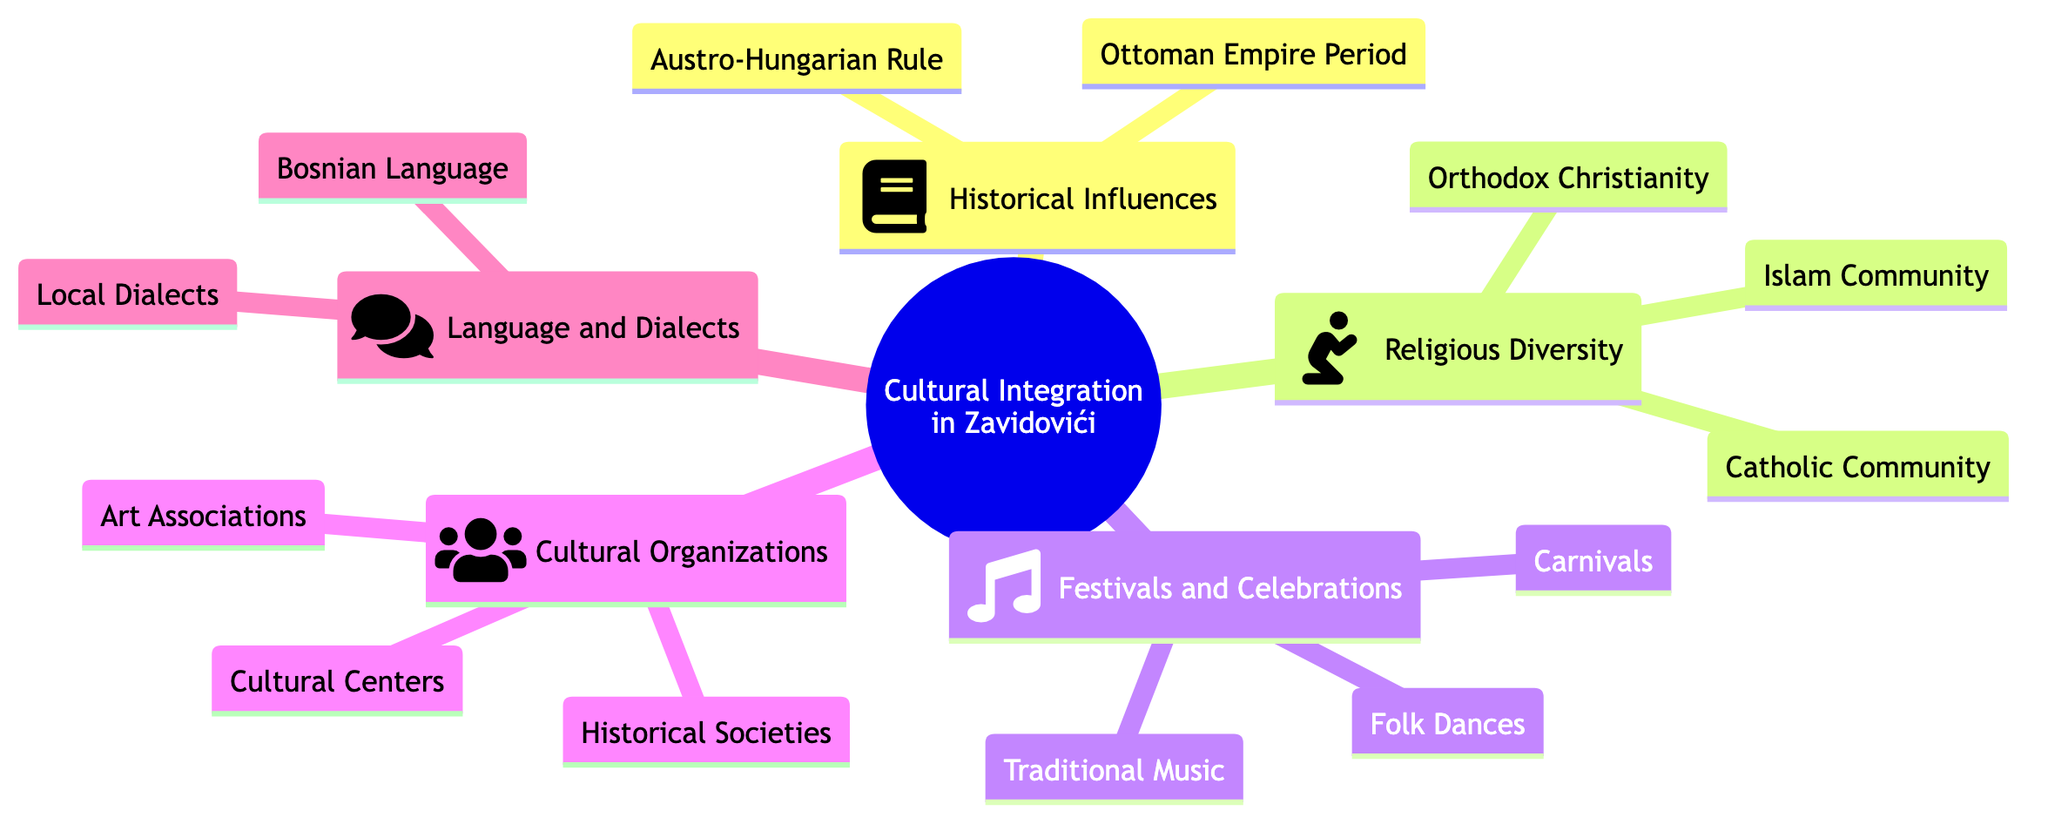What is the central theme of the concept map? The root node, titled "Cultural Integration in Zavidovići," is the main theme presented in the diagram. This can be identified as it is the top-level node and connects to several child nodes.
Answer: Cultural Integration in Zavidovići How many cultural organizations are listed in the diagram? The child node "Cultural Organizations" has three connections leading to "Cultural Centers," "Historical Societies," and "Art Associations," indicating there are three cultural organizations represented.
Answer: 3 Which historical period is included under Historical Influences? The child node "Historical Influences" specifically includes two periods: "Ottoman Empire Period" and "Austro-Hungarian Rule." This can be verified by looking at the connections from the Historical Influences node.
Answer: Ottoman Empire Period, Austro-Hungarian Rule What type of community is included under Religious Diversity? The "Religious Diversity" node includes three distinct communities: "Islam Community," "Orthodox Christianity," and "Catholic Community." Therefore, the answer is any of the communities listed under that node.
Answer: Islam Community Which festival type is included under Festivals and Celebrations? The node "Festivals and Celebrations" includes "Carnivals," "Folk Dances," and "Traditional Music." Any of these items would answer the question, but one example would be selected here.
Answer: Carnivals How many total child nodes are linked under Cultural Integration in Zavidovići? "Cultural Integration in Zavidovići" has five child nodes directly linked: "Historical Influences," "Religious Diversity," "Festivals and Celebrations," "Cultural Organizations," and "Language and Dialects." Counting these gives a total of five.
Answer: 5 What language is associated with Language and Dialects? The child node "Language and Dialects" contains two sub-nodes: "Bosnian Language" and "Local Dialects." Any of these would be a correct answer for a language associated with this node.
Answer: Bosnian Language Which type of festival does the child node "Festivals and Celebrations" NOT include? Upon reviewing the items listed under "Festivals and Celebrations," we see it includes "Carnivals," "Folk Dances," and "Traditional Music." However, it does not mention modern festivals or any specific contemporary events. Therefore, the correct answer would be any type of festival that is not listed.
Answer: Modern Festivals 